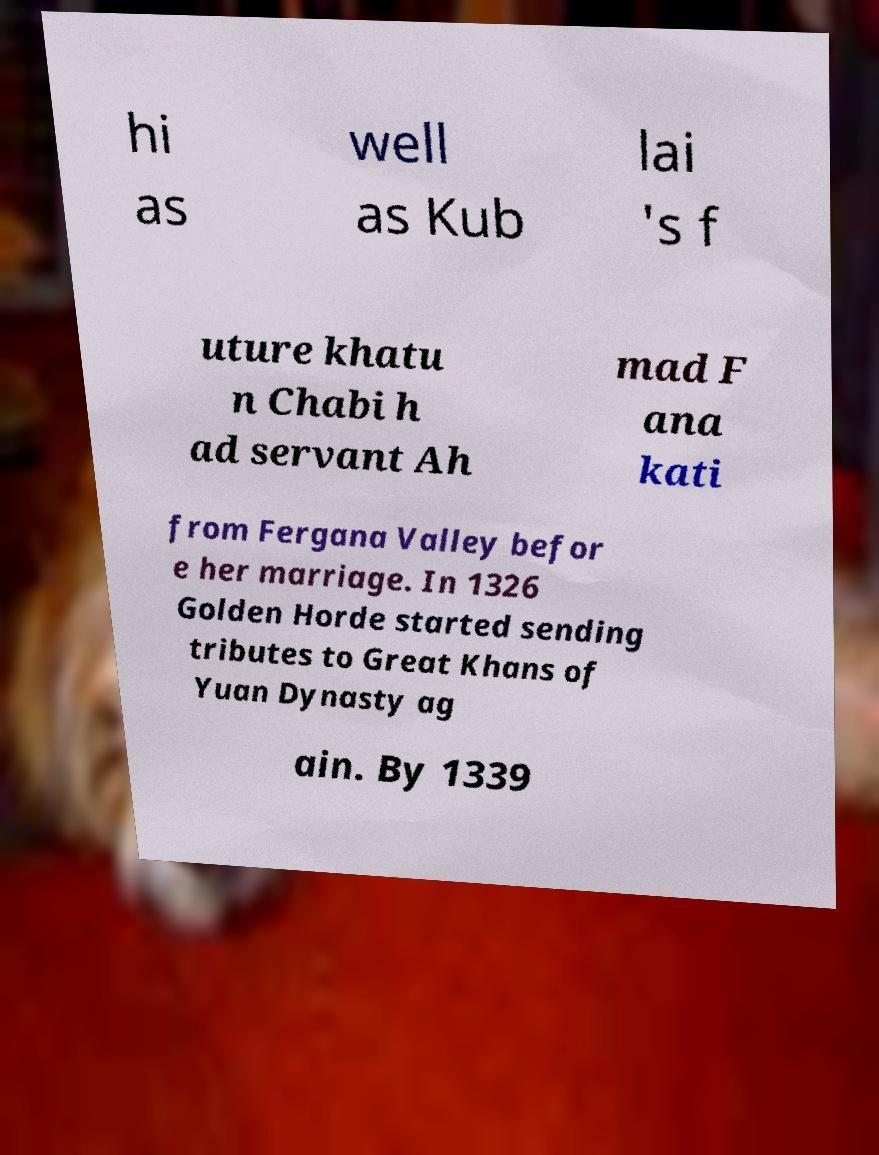For documentation purposes, I need the text within this image transcribed. Could you provide that? hi as well as Kub lai 's f uture khatu n Chabi h ad servant Ah mad F ana kati from Fergana Valley befor e her marriage. In 1326 Golden Horde started sending tributes to Great Khans of Yuan Dynasty ag ain. By 1339 